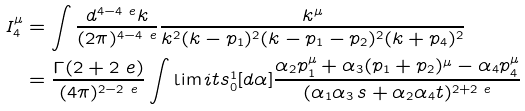<formula> <loc_0><loc_0><loc_500><loc_500>I _ { 4 } ^ { \mu } & = \int \frac { d ^ { 4 - 4 \ e } k } { ( 2 \pi ) ^ { 4 - 4 \ e } } \frac { k ^ { \mu } } { k ^ { 2 } ( k - p _ { 1 } ) ^ { 2 } ( k - p _ { 1 } - p _ { 2 } ) ^ { 2 } ( k + p _ { 4 } ) ^ { 2 } } \\ & = \frac { \Gamma ( 2 + 2 \ e ) } { ( 4 \pi ) ^ { 2 - 2 \ e } } \int \lim i t s _ { 0 } ^ { 1 } [ d \alpha ] \frac { \alpha _ { 2 } p _ { 1 } ^ { \mu } + \alpha _ { 3 } ( p _ { 1 } + p _ { 2 } ) ^ { \mu } - \alpha _ { 4 } p _ { 4 } ^ { \mu } } { ( \alpha _ { 1 } \alpha _ { 3 } \, s + \alpha _ { 2 } \alpha _ { 4 } t ) ^ { 2 + 2 \ e } }</formula> 